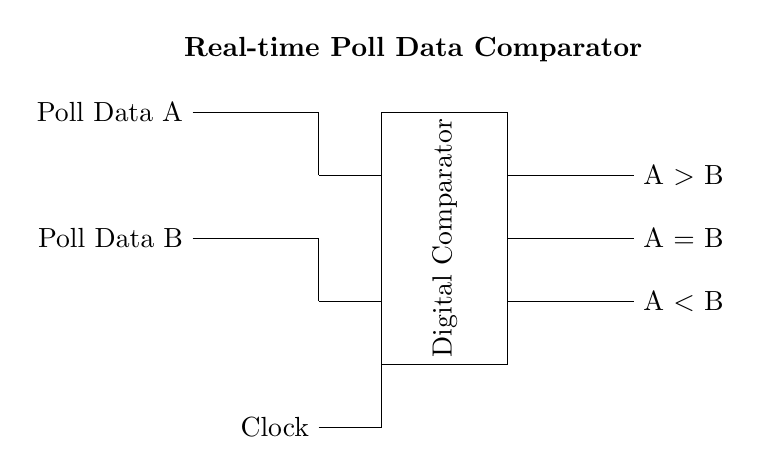What type of circuit is depicted? The circuit in the diagram is a digital comparator, indicated by the label in the center. It takes two inputs and compares them to generate outputs based on their relationship.
Answer: digital comparator How many input signals does the comparator have? The diagram shows two input signals, labeled as Poll Data A and Poll Data B, entering from the left into the comparator.
Answer: two What is the output state when A is greater than B? The circuit provides an output labeled A greater than B on the right side, indicating the result when the first input exceeds the second input.
Answer: A greater than B What component is used to time the operation of this comparator? The circuit includes a Clock input at the bottom, which is a necessary component for synchronous operations, ensuring the comparator functions consistently over time.
Answer: Clock Which output represents equality between the two inputs? The output labeled A equals B is designed to show if both input signals are the same, reflecting on the comparator's functionality.
Answer: A equals B What does the position of the digital comparator suggest about its function? The placement of the digital comparator between the inputs and outputs suggests it processes the comparisons of Poll Data A and Poll Data B and then generates the outputs accordingly based on the comparison results.
Answer: logical processing 